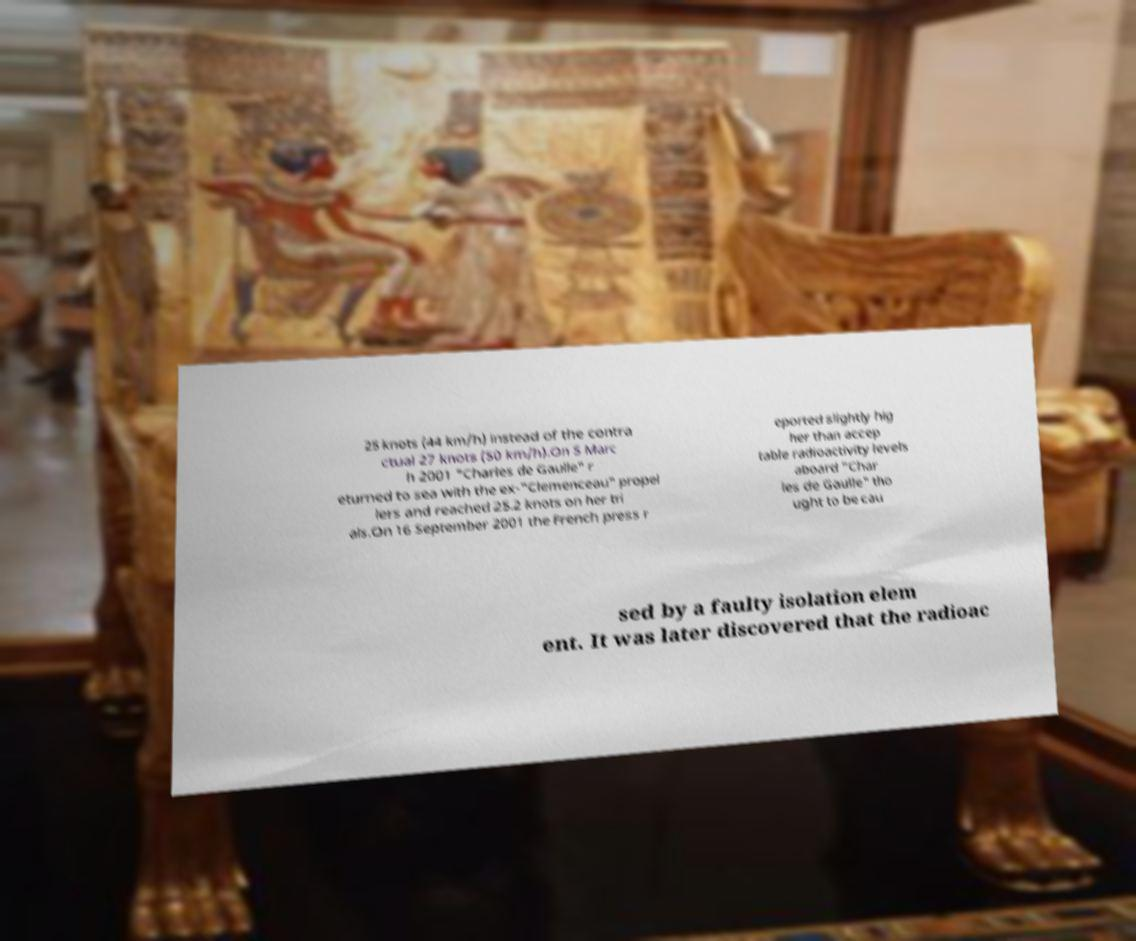Please identify and transcribe the text found in this image. 25 knots (44 km/h) instead of the contra ctual 27 knots (50 km/h).On 5 Marc h 2001 "Charles de Gaulle" r eturned to sea with the ex-"Clemenceau" propel lers and reached 25.2 knots on her tri als.On 16 September 2001 the French press r eported slightly hig her than accep table radioactivity levels aboard "Char les de Gaulle" tho ught to be cau sed by a faulty isolation elem ent. It was later discovered that the radioac 